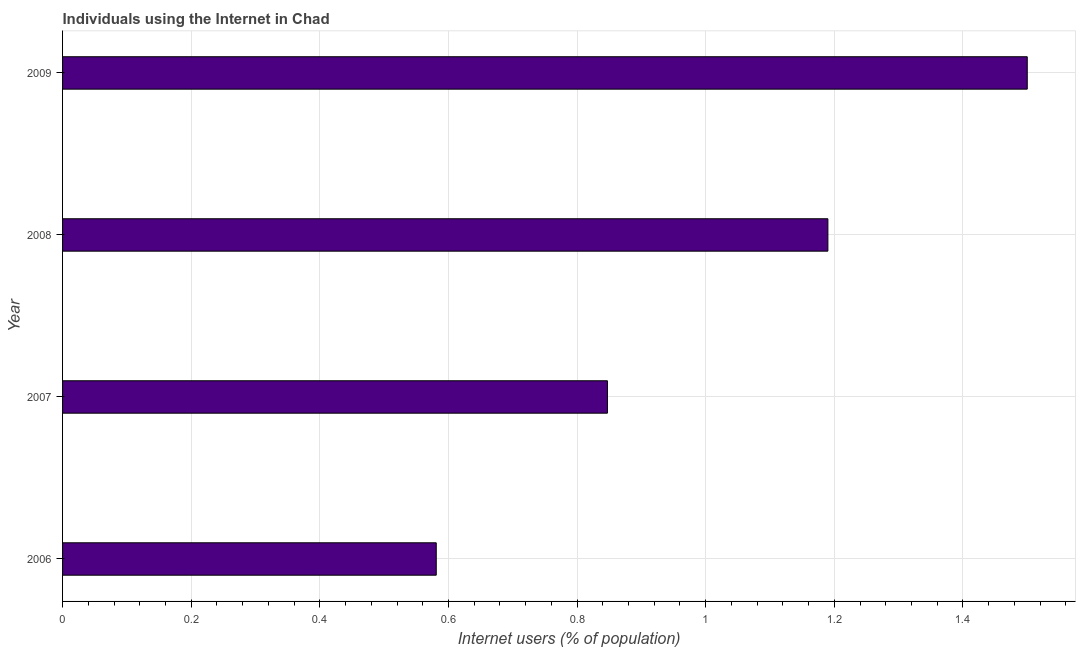Does the graph contain any zero values?
Give a very brief answer. No. What is the title of the graph?
Provide a succinct answer. Individuals using the Internet in Chad. What is the label or title of the X-axis?
Your answer should be very brief. Internet users (% of population). What is the label or title of the Y-axis?
Your answer should be compact. Year. What is the number of internet users in 2007?
Your answer should be very brief. 0.85. Across all years, what is the minimum number of internet users?
Make the answer very short. 0.58. In which year was the number of internet users minimum?
Ensure brevity in your answer.  2006. What is the sum of the number of internet users?
Make the answer very short. 4.12. What is the difference between the number of internet users in 2006 and 2008?
Your answer should be compact. -0.61. What is the median number of internet users?
Your response must be concise. 1.02. What is the ratio of the number of internet users in 2008 to that in 2009?
Your answer should be very brief. 0.79. Is the number of internet users in 2006 less than that in 2009?
Provide a short and direct response. Yes. What is the difference between the highest and the second highest number of internet users?
Offer a very short reply. 0.31. Is the sum of the number of internet users in 2007 and 2008 greater than the maximum number of internet users across all years?
Your answer should be very brief. Yes. In how many years, is the number of internet users greater than the average number of internet users taken over all years?
Make the answer very short. 2. Are all the bars in the graph horizontal?
Make the answer very short. Yes. How many years are there in the graph?
Offer a terse response. 4. What is the difference between two consecutive major ticks on the X-axis?
Your answer should be very brief. 0.2. What is the Internet users (% of population) in 2006?
Provide a succinct answer. 0.58. What is the Internet users (% of population) in 2007?
Your answer should be compact. 0.85. What is the Internet users (% of population) in 2008?
Your answer should be very brief. 1.19. What is the Internet users (% of population) of 2009?
Your answer should be very brief. 1.5. What is the difference between the Internet users (% of population) in 2006 and 2007?
Ensure brevity in your answer.  -0.27. What is the difference between the Internet users (% of population) in 2006 and 2008?
Keep it short and to the point. -0.61. What is the difference between the Internet users (% of population) in 2006 and 2009?
Offer a terse response. -0.92. What is the difference between the Internet users (% of population) in 2007 and 2008?
Give a very brief answer. -0.34. What is the difference between the Internet users (% of population) in 2007 and 2009?
Your answer should be very brief. -0.65. What is the difference between the Internet users (% of population) in 2008 and 2009?
Offer a terse response. -0.31. What is the ratio of the Internet users (% of population) in 2006 to that in 2007?
Your response must be concise. 0.69. What is the ratio of the Internet users (% of population) in 2006 to that in 2008?
Offer a terse response. 0.49. What is the ratio of the Internet users (% of population) in 2006 to that in 2009?
Provide a succinct answer. 0.39. What is the ratio of the Internet users (% of population) in 2007 to that in 2008?
Provide a short and direct response. 0.71. What is the ratio of the Internet users (% of population) in 2007 to that in 2009?
Offer a terse response. 0.56. What is the ratio of the Internet users (% of population) in 2008 to that in 2009?
Your response must be concise. 0.79. 